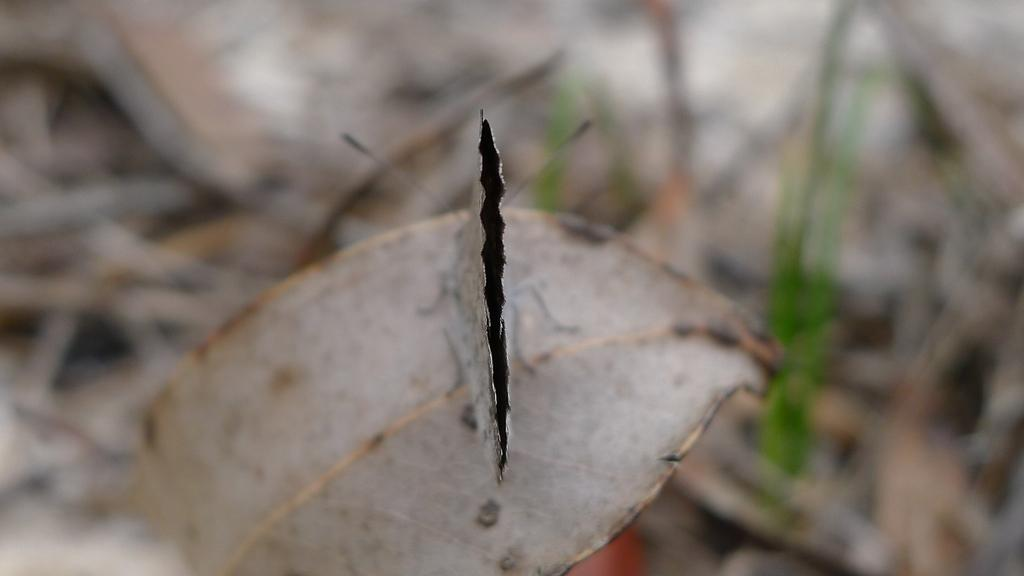What is the main subject of the image? There is a butterfly in the image. Where is the butterfly located in the image? The butterfly is sitting on a dry leaf. Can you describe the background of the image? The background of the image is blurred. What type of soda is being traded in the town depicted in the image? There is no town or soda present in the image; it features a butterfly sitting on a dry leaf with a blurred background. 